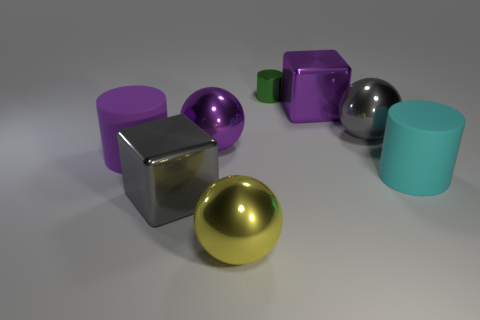There is a metal block that is in front of the purple cylinder; does it have the same size as the sphere behind the big purple ball?
Your response must be concise. Yes. What number of other rubber things have the same shape as the small green thing?
Your answer should be very brief. 2. What is the shape of the tiny green object that is made of the same material as the yellow thing?
Give a very brief answer. Cylinder. What material is the big cylinder that is to the left of the large matte thing that is to the right of the large sphere that is behind the purple ball made of?
Offer a very short reply. Rubber. Is the size of the purple metallic ball the same as the purple object left of the gray metal block?
Provide a succinct answer. Yes. What is the material of the tiny green thing that is the same shape as the cyan object?
Make the answer very short. Metal. What is the size of the cylinder that is behind the big purple metal thing that is left of the metal block that is behind the big gray metal ball?
Your answer should be very brief. Small. Do the yellow thing and the green shiny thing have the same size?
Your answer should be compact. No. What material is the large cylinder on the left side of the large shiny block that is on the right side of the tiny cylinder made of?
Provide a short and direct response. Rubber. There is a big purple metal object to the right of the tiny green shiny cylinder; is its shape the same as the big gray shiny object right of the small green cylinder?
Provide a succinct answer. No. 